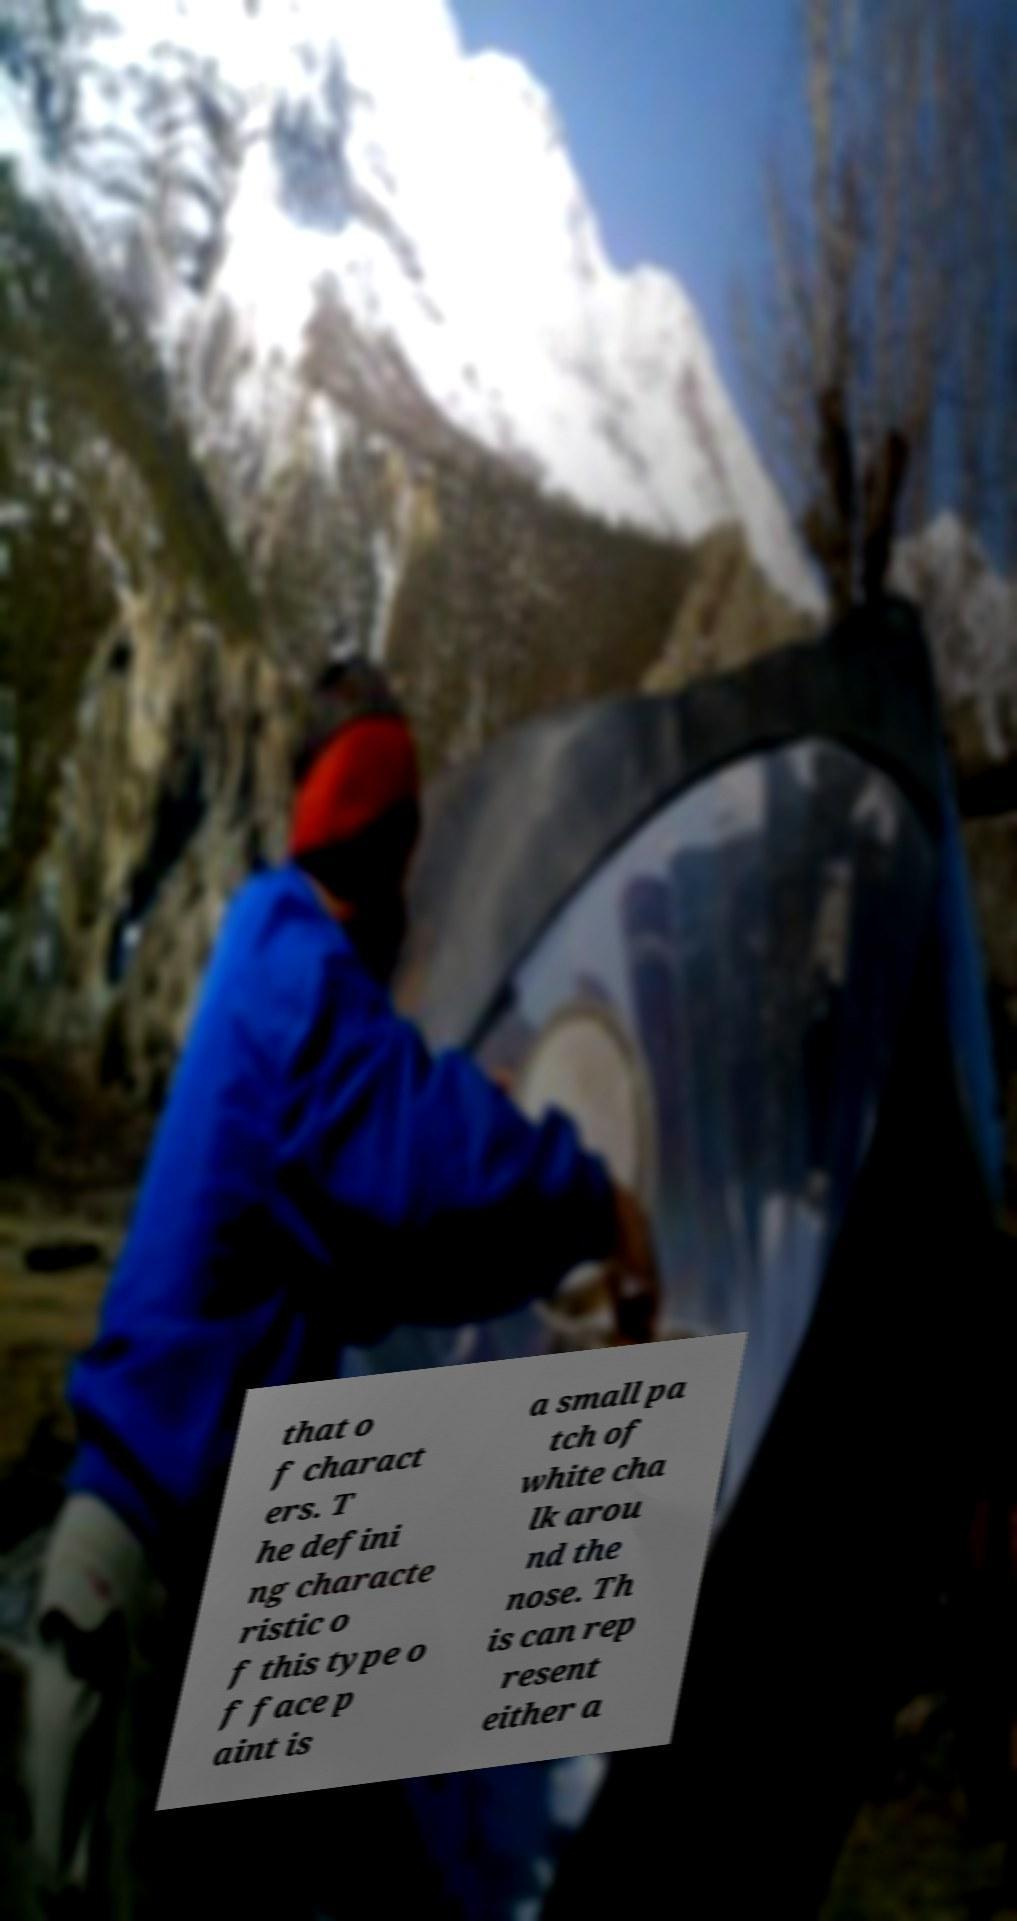I need the written content from this picture converted into text. Can you do that? that o f charact ers. T he defini ng characte ristic o f this type o f face p aint is a small pa tch of white cha lk arou nd the nose. Th is can rep resent either a 